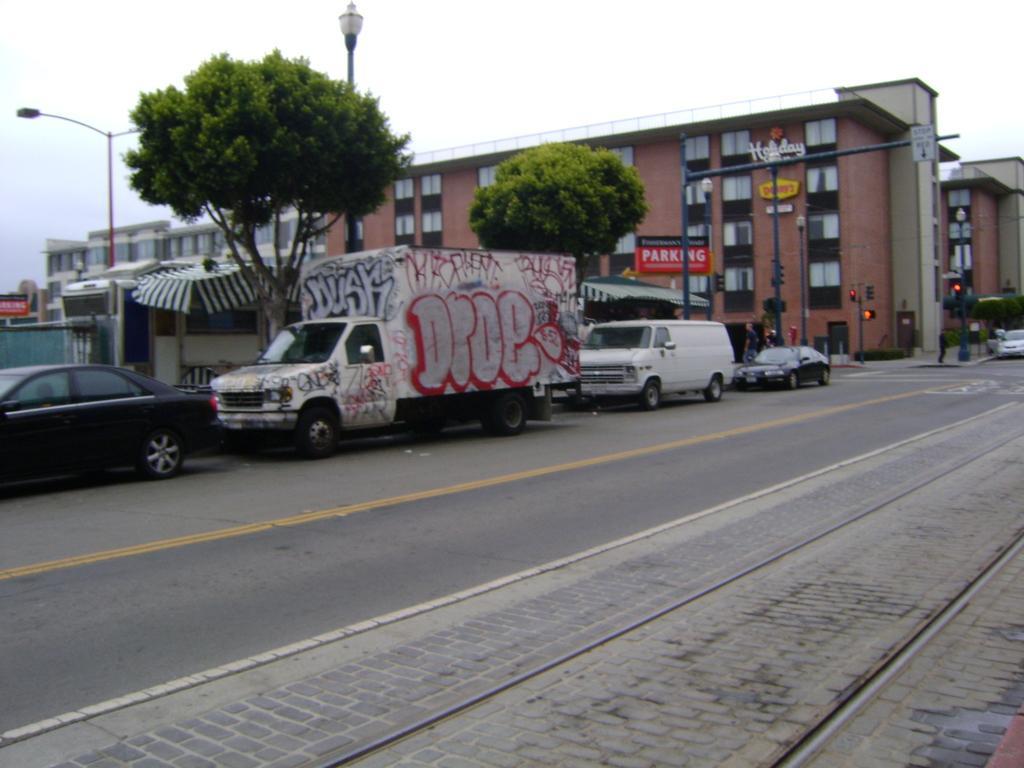Describe this image in one or two sentences. In this image we can see vehicles on the road, trees, tent, buildings, windows, traffic signal poles, light poles, street lights, hoardings, objects and clouds in the sky. 